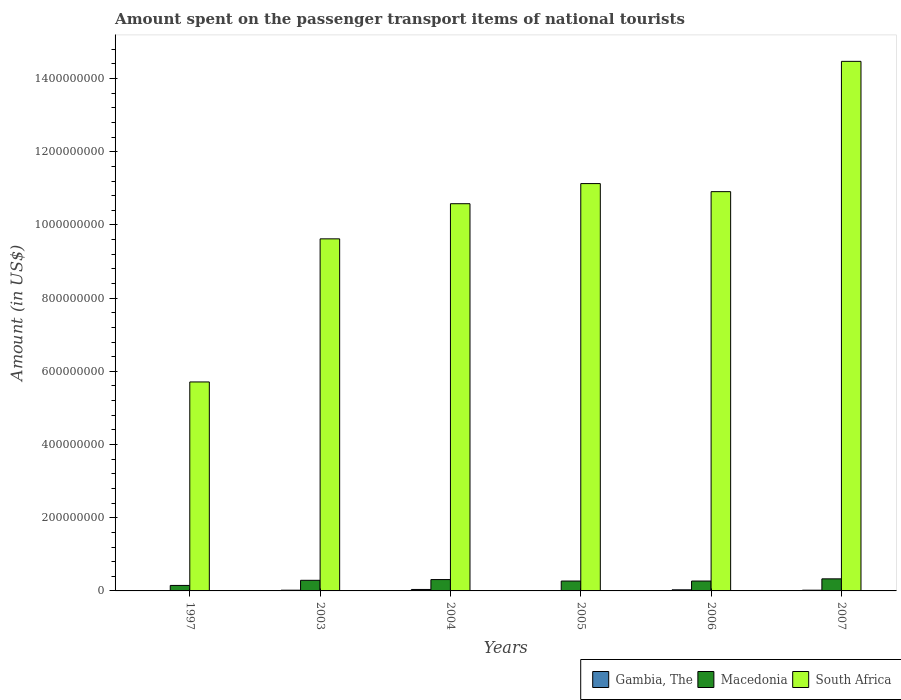Are the number of bars per tick equal to the number of legend labels?
Offer a very short reply. Yes. What is the amount spent on the passenger transport items of national tourists in Macedonia in 2007?
Provide a succinct answer. 3.30e+07. Across all years, what is the maximum amount spent on the passenger transport items of national tourists in Macedonia?
Make the answer very short. 3.30e+07. In which year was the amount spent on the passenger transport items of national tourists in South Africa maximum?
Your answer should be compact. 2007. What is the total amount spent on the passenger transport items of national tourists in South Africa in the graph?
Your answer should be very brief. 6.24e+09. What is the difference between the amount spent on the passenger transport items of national tourists in Macedonia in 1997 and that in 2003?
Ensure brevity in your answer.  -1.40e+07. What is the difference between the amount spent on the passenger transport items of national tourists in Gambia, The in 2006 and the amount spent on the passenger transport items of national tourists in South Africa in 2004?
Provide a succinct answer. -1.06e+09. What is the average amount spent on the passenger transport items of national tourists in South Africa per year?
Make the answer very short. 1.04e+09. In the year 2005, what is the difference between the amount spent on the passenger transport items of national tourists in South Africa and amount spent on the passenger transport items of national tourists in Gambia, The?
Ensure brevity in your answer.  1.11e+09. Is the difference between the amount spent on the passenger transport items of national tourists in South Africa in 1997 and 2006 greater than the difference between the amount spent on the passenger transport items of national tourists in Gambia, The in 1997 and 2006?
Offer a terse response. No. What is the difference between the highest and the lowest amount spent on the passenger transport items of national tourists in Macedonia?
Offer a very short reply. 1.80e+07. Is the sum of the amount spent on the passenger transport items of national tourists in Macedonia in 2003 and 2004 greater than the maximum amount spent on the passenger transport items of national tourists in South Africa across all years?
Offer a very short reply. No. What does the 3rd bar from the left in 2007 represents?
Your response must be concise. South Africa. What does the 2nd bar from the right in 2005 represents?
Your answer should be very brief. Macedonia. Is it the case that in every year, the sum of the amount spent on the passenger transport items of national tourists in South Africa and amount spent on the passenger transport items of national tourists in Gambia, The is greater than the amount spent on the passenger transport items of national tourists in Macedonia?
Make the answer very short. Yes. What is the difference between two consecutive major ticks on the Y-axis?
Offer a very short reply. 2.00e+08. Does the graph contain grids?
Keep it short and to the point. No. Where does the legend appear in the graph?
Ensure brevity in your answer.  Bottom right. How many legend labels are there?
Your response must be concise. 3. How are the legend labels stacked?
Make the answer very short. Horizontal. What is the title of the graph?
Offer a very short reply. Amount spent on the passenger transport items of national tourists. What is the label or title of the Y-axis?
Offer a terse response. Amount (in US$). What is the Amount (in US$) of Macedonia in 1997?
Offer a very short reply. 1.50e+07. What is the Amount (in US$) of South Africa in 1997?
Offer a terse response. 5.71e+08. What is the Amount (in US$) in Macedonia in 2003?
Your response must be concise. 2.90e+07. What is the Amount (in US$) in South Africa in 2003?
Ensure brevity in your answer.  9.62e+08. What is the Amount (in US$) in Macedonia in 2004?
Give a very brief answer. 3.10e+07. What is the Amount (in US$) in South Africa in 2004?
Provide a succinct answer. 1.06e+09. What is the Amount (in US$) in Gambia, The in 2005?
Ensure brevity in your answer.  1.00e+06. What is the Amount (in US$) of Macedonia in 2005?
Offer a terse response. 2.70e+07. What is the Amount (in US$) in South Africa in 2005?
Offer a terse response. 1.11e+09. What is the Amount (in US$) of Macedonia in 2006?
Provide a succinct answer. 2.70e+07. What is the Amount (in US$) of South Africa in 2006?
Make the answer very short. 1.09e+09. What is the Amount (in US$) of Gambia, The in 2007?
Your response must be concise. 2.00e+06. What is the Amount (in US$) of Macedonia in 2007?
Your answer should be compact. 3.30e+07. What is the Amount (in US$) of South Africa in 2007?
Keep it short and to the point. 1.45e+09. Across all years, what is the maximum Amount (in US$) of Gambia, The?
Keep it short and to the point. 4.00e+06. Across all years, what is the maximum Amount (in US$) in Macedonia?
Offer a terse response. 3.30e+07. Across all years, what is the maximum Amount (in US$) of South Africa?
Your answer should be very brief. 1.45e+09. Across all years, what is the minimum Amount (in US$) in Gambia, The?
Your answer should be compact. 1.00e+06. Across all years, what is the minimum Amount (in US$) in Macedonia?
Make the answer very short. 1.50e+07. Across all years, what is the minimum Amount (in US$) in South Africa?
Give a very brief answer. 5.71e+08. What is the total Amount (in US$) in Gambia, The in the graph?
Make the answer very short. 1.30e+07. What is the total Amount (in US$) in Macedonia in the graph?
Your answer should be compact. 1.62e+08. What is the total Amount (in US$) of South Africa in the graph?
Your answer should be compact. 6.24e+09. What is the difference between the Amount (in US$) of Macedonia in 1997 and that in 2003?
Offer a terse response. -1.40e+07. What is the difference between the Amount (in US$) in South Africa in 1997 and that in 2003?
Make the answer very short. -3.91e+08. What is the difference between the Amount (in US$) of Gambia, The in 1997 and that in 2004?
Offer a very short reply. -3.00e+06. What is the difference between the Amount (in US$) of Macedonia in 1997 and that in 2004?
Offer a very short reply. -1.60e+07. What is the difference between the Amount (in US$) in South Africa in 1997 and that in 2004?
Your response must be concise. -4.87e+08. What is the difference between the Amount (in US$) in Macedonia in 1997 and that in 2005?
Offer a very short reply. -1.20e+07. What is the difference between the Amount (in US$) in South Africa in 1997 and that in 2005?
Keep it short and to the point. -5.42e+08. What is the difference between the Amount (in US$) of Macedonia in 1997 and that in 2006?
Your answer should be compact. -1.20e+07. What is the difference between the Amount (in US$) of South Africa in 1997 and that in 2006?
Offer a very short reply. -5.20e+08. What is the difference between the Amount (in US$) in Macedonia in 1997 and that in 2007?
Your response must be concise. -1.80e+07. What is the difference between the Amount (in US$) in South Africa in 1997 and that in 2007?
Make the answer very short. -8.76e+08. What is the difference between the Amount (in US$) in Macedonia in 2003 and that in 2004?
Your answer should be very brief. -2.00e+06. What is the difference between the Amount (in US$) of South Africa in 2003 and that in 2004?
Provide a short and direct response. -9.60e+07. What is the difference between the Amount (in US$) in Gambia, The in 2003 and that in 2005?
Provide a succinct answer. 1.00e+06. What is the difference between the Amount (in US$) in South Africa in 2003 and that in 2005?
Provide a short and direct response. -1.51e+08. What is the difference between the Amount (in US$) in Macedonia in 2003 and that in 2006?
Your response must be concise. 2.00e+06. What is the difference between the Amount (in US$) of South Africa in 2003 and that in 2006?
Your answer should be very brief. -1.29e+08. What is the difference between the Amount (in US$) in Gambia, The in 2003 and that in 2007?
Give a very brief answer. 0. What is the difference between the Amount (in US$) of Macedonia in 2003 and that in 2007?
Ensure brevity in your answer.  -4.00e+06. What is the difference between the Amount (in US$) in South Africa in 2003 and that in 2007?
Your answer should be very brief. -4.85e+08. What is the difference between the Amount (in US$) in Macedonia in 2004 and that in 2005?
Give a very brief answer. 4.00e+06. What is the difference between the Amount (in US$) in South Africa in 2004 and that in 2005?
Your answer should be compact. -5.50e+07. What is the difference between the Amount (in US$) in Macedonia in 2004 and that in 2006?
Your response must be concise. 4.00e+06. What is the difference between the Amount (in US$) in South Africa in 2004 and that in 2006?
Provide a succinct answer. -3.30e+07. What is the difference between the Amount (in US$) of South Africa in 2004 and that in 2007?
Make the answer very short. -3.89e+08. What is the difference between the Amount (in US$) of South Africa in 2005 and that in 2006?
Your response must be concise. 2.20e+07. What is the difference between the Amount (in US$) of Macedonia in 2005 and that in 2007?
Make the answer very short. -6.00e+06. What is the difference between the Amount (in US$) of South Africa in 2005 and that in 2007?
Give a very brief answer. -3.34e+08. What is the difference between the Amount (in US$) in Gambia, The in 2006 and that in 2007?
Keep it short and to the point. 1.00e+06. What is the difference between the Amount (in US$) of Macedonia in 2006 and that in 2007?
Keep it short and to the point. -6.00e+06. What is the difference between the Amount (in US$) of South Africa in 2006 and that in 2007?
Give a very brief answer. -3.56e+08. What is the difference between the Amount (in US$) in Gambia, The in 1997 and the Amount (in US$) in Macedonia in 2003?
Your response must be concise. -2.80e+07. What is the difference between the Amount (in US$) in Gambia, The in 1997 and the Amount (in US$) in South Africa in 2003?
Provide a short and direct response. -9.61e+08. What is the difference between the Amount (in US$) of Macedonia in 1997 and the Amount (in US$) of South Africa in 2003?
Offer a terse response. -9.47e+08. What is the difference between the Amount (in US$) of Gambia, The in 1997 and the Amount (in US$) of Macedonia in 2004?
Provide a short and direct response. -3.00e+07. What is the difference between the Amount (in US$) in Gambia, The in 1997 and the Amount (in US$) in South Africa in 2004?
Offer a terse response. -1.06e+09. What is the difference between the Amount (in US$) of Macedonia in 1997 and the Amount (in US$) of South Africa in 2004?
Keep it short and to the point. -1.04e+09. What is the difference between the Amount (in US$) in Gambia, The in 1997 and the Amount (in US$) in Macedonia in 2005?
Give a very brief answer. -2.60e+07. What is the difference between the Amount (in US$) of Gambia, The in 1997 and the Amount (in US$) of South Africa in 2005?
Your response must be concise. -1.11e+09. What is the difference between the Amount (in US$) of Macedonia in 1997 and the Amount (in US$) of South Africa in 2005?
Offer a terse response. -1.10e+09. What is the difference between the Amount (in US$) in Gambia, The in 1997 and the Amount (in US$) in Macedonia in 2006?
Your answer should be very brief. -2.60e+07. What is the difference between the Amount (in US$) in Gambia, The in 1997 and the Amount (in US$) in South Africa in 2006?
Keep it short and to the point. -1.09e+09. What is the difference between the Amount (in US$) in Macedonia in 1997 and the Amount (in US$) in South Africa in 2006?
Provide a succinct answer. -1.08e+09. What is the difference between the Amount (in US$) in Gambia, The in 1997 and the Amount (in US$) in Macedonia in 2007?
Your response must be concise. -3.20e+07. What is the difference between the Amount (in US$) in Gambia, The in 1997 and the Amount (in US$) in South Africa in 2007?
Ensure brevity in your answer.  -1.45e+09. What is the difference between the Amount (in US$) in Macedonia in 1997 and the Amount (in US$) in South Africa in 2007?
Keep it short and to the point. -1.43e+09. What is the difference between the Amount (in US$) of Gambia, The in 2003 and the Amount (in US$) of Macedonia in 2004?
Provide a succinct answer. -2.90e+07. What is the difference between the Amount (in US$) of Gambia, The in 2003 and the Amount (in US$) of South Africa in 2004?
Provide a succinct answer. -1.06e+09. What is the difference between the Amount (in US$) of Macedonia in 2003 and the Amount (in US$) of South Africa in 2004?
Provide a succinct answer. -1.03e+09. What is the difference between the Amount (in US$) of Gambia, The in 2003 and the Amount (in US$) of Macedonia in 2005?
Your answer should be very brief. -2.50e+07. What is the difference between the Amount (in US$) in Gambia, The in 2003 and the Amount (in US$) in South Africa in 2005?
Ensure brevity in your answer.  -1.11e+09. What is the difference between the Amount (in US$) of Macedonia in 2003 and the Amount (in US$) of South Africa in 2005?
Give a very brief answer. -1.08e+09. What is the difference between the Amount (in US$) of Gambia, The in 2003 and the Amount (in US$) of Macedonia in 2006?
Offer a terse response. -2.50e+07. What is the difference between the Amount (in US$) of Gambia, The in 2003 and the Amount (in US$) of South Africa in 2006?
Ensure brevity in your answer.  -1.09e+09. What is the difference between the Amount (in US$) of Macedonia in 2003 and the Amount (in US$) of South Africa in 2006?
Provide a succinct answer. -1.06e+09. What is the difference between the Amount (in US$) of Gambia, The in 2003 and the Amount (in US$) of Macedonia in 2007?
Provide a succinct answer. -3.10e+07. What is the difference between the Amount (in US$) of Gambia, The in 2003 and the Amount (in US$) of South Africa in 2007?
Offer a very short reply. -1.44e+09. What is the difference between the Amount (in US$) in Macedonia in 2003 and the Amount (in US$) in South Africa in 2007?
Your response must be concise. -1.42e+09. What is the difference between the Amount (in US$) of Gambia, The in 2004 and the Amount (in US$) of Macedonia in 2005?
Provide a short and direct response. -2.30e+07. What is the difference between the Amount (in US$) in Gambia, The in 2004 and the Amount (in US$) in South Africa in 2005?
Keep it short and to the point. -1.11e+09. What is the difference between the Amount (in US$) of Macedonia in 2004 and the Amount (in US$) of South Africa in 2005?
Make the answer very short. -1.08e+09. What is the difference between the Amount (in US$) in Gambia, The in 2004 and the Amount (in US$) in Macedonia in 2006?
Make the answer very short. -2.30e+07. What is the difference between the Amount (in US$) of Gambia, The in 2004 and the Amount (in US$) of South Africa in 2006?
Offer a very short reply. -1.09e+09. What is the difference between the Amount (in US$) of Macedonia in 2004 and the Amount (in US$) of South Africa in 2006?
Offer a terse response. -1.06e+09. What is the difference between the Amount (in US$) of Gambia, The in 2004 and the Amount (in US$) of Macedonia in 2007?
Provide a short and direct response. -2.90e+07. What is the difference between the Amount (in US$) of Gambia, The in 2004 and the Amount (in US$) of South Africa in 2007?
Make the answer very short. -1.44e+09. What is the difference between the Amount (in US$) of Macedonia in 2004 and the Amount (in US$) of South Africa in 2007?
Offer a terse response. -1.42e+09. What is the difference between the Amount (in US$) in Gambia, The in 2005 and the Amount (in US$) in Macedonia in 2006?
Your response must be concise. -2.60e+07. What is the difference between the Amount (in US$) of Gambia, The in 2005 and the Amount (in US$) of South Africa in 2006?
Your answer should be very brief. -1.09e+09. What is the difference between the Amount (in US$) of Macedonia in 2005 and the Amount (in US$) of South Africa in 2006?
Your answer should be compact. -1.06e+09. What is the difference between the Amount (in US$) in Gambia, The in 2005 and the Amount (in US$) in Macedonia in 2007?
Offer a terse response. -3.20e+07. What is the difference between the Amount (in US$) in Gambia, The in 2005 and the Amount (in US$) in South Africa in 2007?
Offer a very short reply. -1.45e+09. What is the difference between the Amount (in US$) of Macedonia in 2005 and the Amount (in US$) of South Africa in 2007?
Keep it short and to the point. -1.42e+09. What is the difference between the Amount (in US$) in Gambia, The in 2006 and the Amount (in US$) in Macedonia in 2007?
Make the answer very short. -3.00e+07. What is the difference between the Amount (in US$) in Gambia, The in 2006 and the Amount (in US$) in South Africa in 2007?
Ensure brevity in your answer.  -1.44e+09. What is the difference between the Amount (in US$) in Macedonia in 2006 and the Amount (in US$) in South Africa in 2007?
Your response must be concise. -1.42e+09. What is the average Amount (in US$) of Gambia, The per year?
Offer a very short reply. 2.17e+06. What is the average Amount (in US$) in Macedonia per year?
Your response must be concise. 2.70e+07. What is the average Amount (in US$) in South Africa per year?
Offer a terse response. 1.04e+09. In the year 1997, what is the difference between the Amount (in US$) in Gambia, The and Amount (in US$) in Macedonia?
Keep it short and to the point. -1.40e+07. In the year 1997, what is the difference between the Amount (in US$) in Gambia, The and Amount (in US$) in South Africa?
Make the answer very short. -5.70e+08. In the year 1997, what is the difference between the Amount (in US$) in Macedonia and Amount (in US$) in South Africa?
Keep it short and to the point. -5.56e+08. In the year 2003, what is the difference between the Amount (in US$) in Gambia, The and Amount (in US$) in Macedonia?
Keep it short and to the point. -2.70e+07. In the year 2003, what is the difference between the Amount (in US$) of Gambia, The and Amount (in US$) of South Africa?
Ensure brevity in your answer.  -9.60e+08. In the year 2003, what is the difference between the Amount (in US$) of Macedonia and Amount (in US$) of South Africa?
Make the answer very short. -9.33e+08. In the year 2004, what is the difference between the Amount (in US$) of Gambia, The and Amount (in US$) of Macedonia?
Offer a terse response. -2.70e+07. In the year 2004, what is the difference between the Amount (in US$) in Gambia, The and Amount (in US$) in South Africa?
Offer a very short reply. -1.05e+09. In the year 2004, what is the difference between the Amount (in US$) of Macedonia and Amount (in US$) of South Africa?
Keep it short and to the point. -1.03e+09. In the year 2005, what is the difference between the Amount (in US$) of Gambia, The and Amount (in US$) of Macedonia?
Your answer should be very brief. -2.60e+07. In the year 2005, what is the difference between the Amount (in US$) of Gambia, The and Amount (in US$) of South Africa?
Offer a very short reply. -1.11e+09. In the year 2005, what is the difference between the Amount (in US$) of Macedonia and Amount (in US$) of South Africa?
Offer a terse response. -1.09e+09. In the year 2006, what is the difference between the Amount (in US$) of Gambia, The and Amount (in US$) of Macedonia?
Your answer should be very brief. -2.40e+07. In the year 2006, what is the difference between the Amount (in US$) in Gambia, The and Amount (in US$) in South Africa?
Your response must be concise. -1.09e+09. In the year 2006, what is the difference between the Amount (in US$) in Macedonia and Amount (in US$) in South Africa?
Keep it short and to the point. -1.06e+09. In the year 2007, what is the difference between the Amount (in US$) of Gambia, The and Amount (in US$) of Macedonia?
Offer a terse response. -3.10e+07. In the year 2007, what is the difference between the Amount (in US$) of Gambia, The and Amount (in US$) of South Africa?
Offer a terse response. -1.44e+09. In the year 2007, what is the difference between the Amount (in US$) of Macedonia and Amount (in US$) of South Africa?
Your answer should be very brief. -1.41e+09. What is the ratio of the Amount (in US$) of Macedonia in 1997 to that in 2003?
Provide a short and direct response. 0.52. What is the ratio of the Amount (in US$) of South Africa in 1997 to that in 2003?
Provide a short and direct response. 0.59. What is the ratio of the Amount (in US$) of Macedonia in 1997 to that in 2004?
Offer a terse response. 0.48. What is the ratio of the Amount (in US$) in South Africa in 1997 to that in 2004?
Provide a short and direct response. 0.54. What is the ratio of the Amount (in US$) in Macedonia in 1997 to that in 2005?
Ensure brevity in your answer.  0.56. What is the ratio of the Amount (in US$) of South Africa in 1997 to that in 2005?
Make the answer very short. 0.51. What is the ratio of the Amount (in US$) of Macedonia in 1997 to that in 2006?
Provide a succinct answer. 0.56. What is the ratio of the Amount (in US$) of South Africa in 1997 to that in 2006?
Provide a short and direct response. 0.52. What is the ratio of the Amount (in US$) in Macedonia in 1997 to that in 2007?
Provide a succinct answer. 0.45. What is the ratio of the Amount (in US$) of South Africa in 1997 to that in 2007?
Offer a very short reply. 0.39. What is the ratio of the Amount (in US$) of Macedonia in 2003 to that in 2004?
Give a very brief answer. 0.94. What is the ratio of the Amount (in US$) in South Africa in 2003 to that in 2004?
Provide a succinct answer. 0.91. What is the ratio of the Amount (in US$) in Macedonia in 2003 to that in 2005?
Provide a succinct answer. 1.07. What is the ratio of the Amount (in US$) of South Africa in 2003 to that in 2005?
Your response must be concise. 0.86. What is the ratio of the Amount (in US$) of Macedonia in 2003 to that in 2006?
Offer a terse response. 1.07. What is the ratio of the Amount (in US$) of South Africa in 2003 to that in 2006?
Keep it short and to the point. 0.88. What is the ratio of the Amount (in US$) of Gambia, The in 2003 to that in 2007?
Provide a short and direct response. 1. What is the ratio of the Amount (in US$) of Macedonia in 2003 to that in 2007?
Make the answer very short. 0.88. What is the ratio of the Amount (in US$) of South Africa in 2003 to that in 2007?
Your answer should be very brief. 0.66. What is the ratio of the Amount (in US$) of Macedonia in 2004 to that in 2005?
Offer a terse response. 1.15. What is the ratio of the Amount (in US$) in South Africa in 2004 to that in 2005?
Provide a short and direct response. 0.95. What is the ratio of the Amount (in US$) of Macedonia in 2004 to that in 2006?
Make the answer very short. 1.15. What is the ratio of the Amount (in US$) in South Africa in 2004 to that in 2006?
Your response must be concise. 0.97. What is the ratio of the Amount (in US$) of Gambia, The in 2004 to that in 2007?
Your response must be concise. 2. What is the ratio of the Amount (in US$) of Macedonia in 2004 to that in 2007?
Your response must be concise. 0.94. What is the ratio of the Amount (in US$) of South Africa in 2004 to that in 2007?
Your response must be concise. 0.73. What is the ratio of the Amount (in US$) in South Africa in 2005 to that in 2006?
Your answer should be compact. 1.02. What is the ratio of the Amount (in US$) of Gambia, The in 2005 to that in 2007?
Offer a terse response. 0.5. What is the ratio of the Amount (in US$) of Macedonia in 2005 to that in 2007?
Offer a terse response. 0.82. What is the ratio of the Amount (in US$) in South Africa in 2005 to that in 2007?
Make the answer very short. 0.77. What is the ratio of the Amount (in US$) in Gambia, The in 2006 to that in 2007?
Give a very brief answer. 1.5. What is the ratio of the Amount (in US$) of Macedonia in 2006 to that in 2007?
Ensure brevity in your answer.  0.82. What is the ratio of the Amount (in US$) of South Africa in 2006 to that in 2007?
Provide a succinct answer. 0.75. What is the difference between the highest and the second highest Amount (in US$) in Gambia, The?
Your answer should be very brief. 1.00e+06. What is the difference between the highest and the second highest Amount (in US$) of Macedonia?
Your answer should be compact. 2.00e+06. What is the difference between the highest and the second highest Amount (in US$) in South Africa?
Offer a terse response. 3.34e+08. What is the difference between the highest and the lowest Amount (in US$) of Gambia, The?
Offer a very short reply. 3.00e+06. What is the difference between the highest and the lowest Amount (in US$) in Macedonia?
Your answer should be very brief. 1.80e+07. What is the difference between the highest and the lowest Amount (in US$) in South Africa?
Your answer should be very brief. 8.76e+08. 